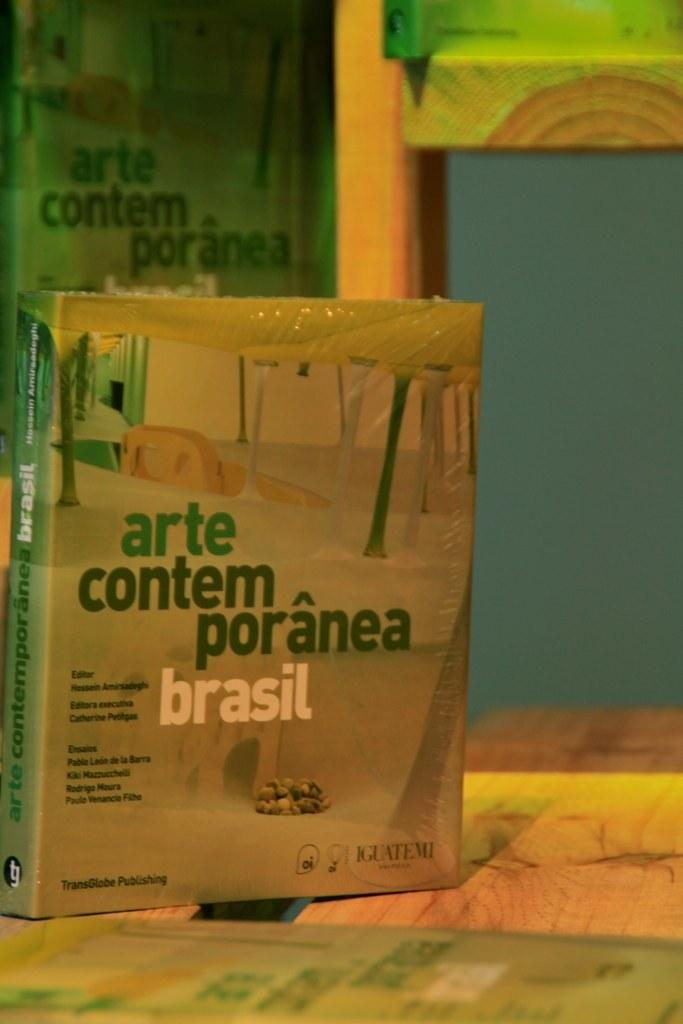<image>
Provide a brief description of the given image. A book with a title that is in Portuguese.. 